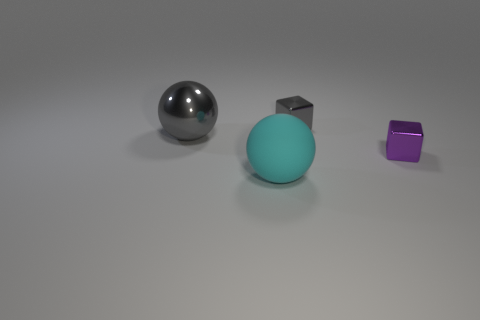How many big blue metal cubes are there? There are no big blue metal cubes in the image. We can see one small purple cube and one metallic sphere, along with a larger teal sphere. 